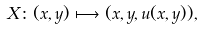<formula> <loc_0><loc_0><loc_500><loc_500>X \colon ( x , y ) & \longmapsto ( x , y , u ( x , y ) ) ,</formula> 